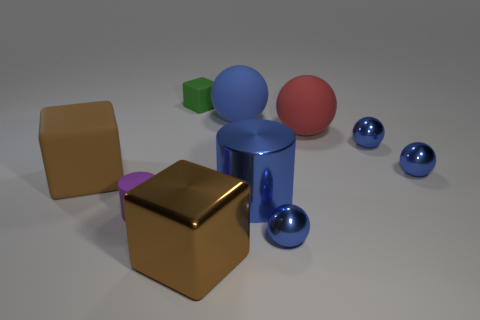Subtract all cyan cylinders. How many blue balls are left? 4 Subtract 1 balls. How many balls are left? 4 Subtract all gray balls. Subtract all cyan cylinders. How many balls are left? 5 Subtract all blocks. How many objects are left? 7 Add 6 green matte things. How many green matte things are left? 7 Add 7 brown matte blocks. How many brown matte blocks exist? 8 Subtract 0 yellow cubes. How many objects are left? 10 Subtract all tiny objects. Subtract all small blue metal things. How many objects are left? 2 